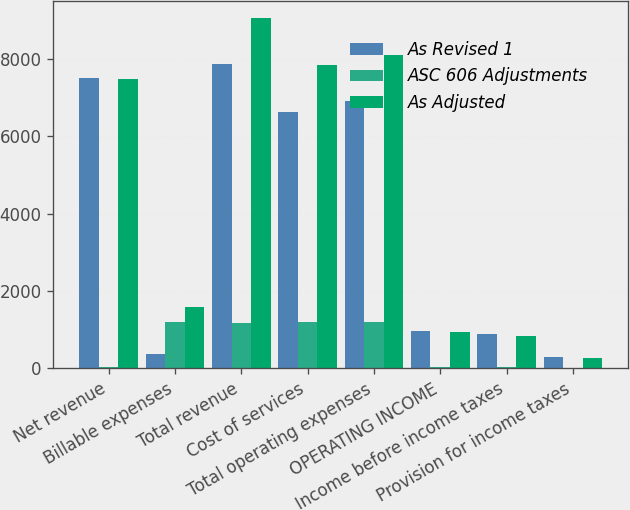Convert chart. <chart><loc_0><loc_0><loc_500><loc_500><stacked_bar_chart><ecel><fcel>Net revenue<fcel>Billable expenses<fcel>Total revenue<fcel>Cost of services<fcel>Total operating expenses<fcel>OPERATING INCOME<fcel>Income before income taxes<fcel>Provision for income taxes<nl><fcel>As Revised 1<fcel>7508.7<fcel>373.7<fcel>7882.4<fcel>6633.2<fcel>6908.8<fcel>973.6<fcel>876<fcel>281.9<nl><fcel>ASC 606 Adjustments<fcel>35.2<fcel>1200.4<fcel>1165.2<fcel>1200.4<fcel>1200.4<fcel>35.2<fcel>35.2<fcel>10.6<nl><fcel>As Adjusted<fcel>7473.5<fcel>1574.1<fcel>9047.6<fcel>7833.6<fcel>8109.2<fcel>938.4<fcel>840.8<fcel>271.3<nl></chart> 